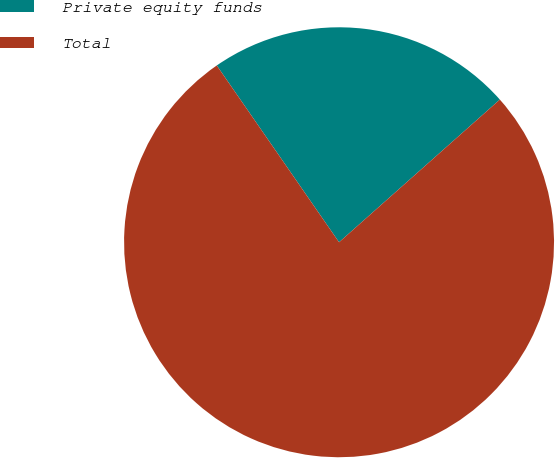<chart> <loc_0><loc_0><loc_500><loc_500><pie_chart><fcel>Private equity funds<fcel>Total<nl><fcel>23.08%<fcel>76.92%<nl></chart> 